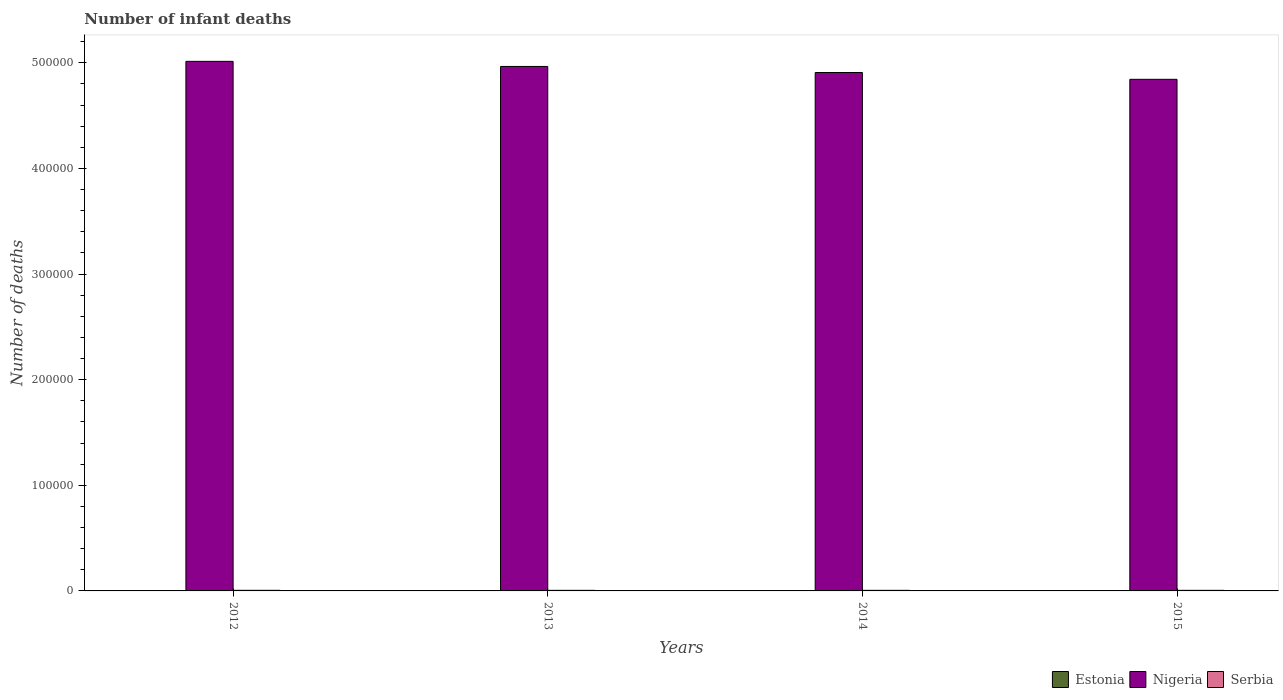How many different coloured bars are there?
Make the answer very short. 3. Are the number of bars on each tick of the X-axis equal?
Give a very brief answer. Yes. How many bars are there on the 3rd tick from the left?
Make the answer very short. 3. How many bars are there on the 4th tick from the right?
Ensure brevity in your answer.  3. What is the label of the 1st group of bars from the left?
Give a very brief answer. 2012. Across all years, what is the maximum number of infant deaths in Nigeria?
Ensure brevity in your answer.  5.01e+05. Across all years, what is the minimum number of infant deaths in Serbia?
Offer a very short reply. 547. In which year was the number of infant deaths in Serbia minimum?
Give a very brief answer. 2015. What is the total number of infant deaths in Estonia in the graph?
Keep it short and to the point. 138. What is the difference between the number of infant deaths in Nigeria in 2012 and that in 2013?
Provide a succinct answer. 4823. What is the difference between the number of infant deaths in Serbia in 2015 and the number of infant deaths in Nigeria in 2012?
Make the answer very short. -5.01e+05. What is the average number of infant deaths in Nigeria per year?
Your answer should be very brief. 4.93e+05. In the year 2015, what is the difference between the number of infant deaths in Serbia and number of infant deaths in Nigeria?
Your answer should be compact. -4.84e+05. What is the ratio of the number of infant deaths in Nigeria in 2013 to that in 2014?
Offer a very short reply. 1.01. Is the number of infant deaths in Serbia in 2012 less than that in 2013?
Provide a short and direct response. No. Is the difference between the number of infant deaths in Serbia in 2014 and 2015 greater than the difference between the number of infant deaths in Nigeria in 2014 and 2015?
Give a very brief answer. No. What is the difference between the highest and the second highest number of infant deaths in Estonia?
Your answer should be compact. 6. In how many years, is the number of infant deaths in Serbia greater than the average number of infant deaths in Serbia taken over all years?
Provide a short and direct response. 1. Is the sum of the number of infant deaths in Estonia in 2014 and 2015 greater than the maximum number of infant deaths in Nigeria across all years?
Give a very brief answer. No. What does the 2nd bar from the left in 2012 represents?
Give a very brief answer. Nigeria. What does the 2nd bar from the right in 2013 represents?
Offer a very short reply. Nigeria. How many bars are there?
Make the answer very short. 12. What is the difference between two consecutive major ticks on the Y-axis?
Your answer should be very brief. 1.00e+05. Are the values on the major ticks of Y-axis written in scientific E-notation?
Your answer should be compact. No. Does the graph contain any zero values?
Provide a succinct answer. No. Where does the legend appear in the graph?
Provide a short and direct response. Bottom right. How are the legend labels stacked?
Your answer should be compact. Horizontal. What is the title of the graph?
Provide a short and direct response. Number of infant deaths. What is the label or title of the Y-axis?
Offer a very short reply. Number of deaths. What is the Number of deaths in Estonia in 2012?
Your response must be concise. 42. What is the Number of deaths in Nigeria in 2012?
Ensure brevity in your answer.  5.01e+05. What is the Number of deaths of Serbia in 2012?
Provide a short and direct response. 567. What is the Number of deaths of Estonia in 2013?
Your answer should be compact. 36. What is the Number of deaths in Nigeria in 2013?
Give a very brief answer. 4.97e+05. What is the Number of deaths of Serbia in 2013?
Ensure brevity in your answer.  552. What is the Number of deaths in Estonia in 2014?
Offer a very short reply. 32. What is the Number of deaths in Nigeria in 2014?
Provide a succinct answer. 4.91e+05. What is the Number of deaths in Serbia in 2014?
Offer a very short reply. 555. What is the Number of deaths in Nigeria in 2015?
Your response must be concise. 4.84e+05. What is the Number of deaths in Serbia in 2015?
Keep it short and to the point. 547. Across all years, what is the maximum Number of deaths of Estonia?
Offer a very short reply. 42. Across all years, what is the maximum Number of deaths in Nigeria?
Your answer should be very brief. 5.01e+05. Across all years, what is the maximum Number of deaths of Serbia?
Your answer should be compact. 567. Across all years, what is the minimum Number of deaths of Nigeria?
Offer a terse response. 4.84e+05. Across all years, what is the minimum Number of deaths in Serbia?
Give a very brief answer. 547. What is the total Number of deaths of Estonia in the graph?
Offer a terse response. 138. What is the total Number of deaths of Nigeria in the graph?
Make the answer very short. 1.97e+06. What is the total Number of deaths of Serbia in the graph?
Your response must be concise. 2221. What is the difference between the Number of deaths in Nigeria in 2012 and that in 2013?
Your answer should be very brief. 4823. What is the difference between the Number of deaths of Estonia in 2012 and that in 2014?
Offer a terse response. 10. What is the difference between the Number of deaths of Nigeria in 2012 and that in 2014?
Give a very brief answer. 1.06e+04. What is the difference between the Number of deaths of Serbia in 2012 and that in 2014?
Your answer should be very brief. 12. What is the difference between the Number of deaths in Estonia in 2012 and that in 2015?
Give a very brief answer. 14. What is the difference between the Number of deaths of Nigeria in 2012 and that in 2015?
Ensure brevity in your answer.  1.70e+04. What is the difference between the Number of deaths of Estonia in 2013 and that in 2014?
Keep it short and to the point. 4. What is the difference between the Number of deaths in Nigeria in 2013 and that in 2014?
Your answer should be very brief. 5749. What is the difference between the Number of deaths in Serbia in 2013 and that in 2014?
Make the answer very short. -3. What is the difference between the Number of deaths of Nigeria in 2013 and that in 2015?
Your response must be concise. 1.22e+04. What is the difference between the Number of deaths in Nigeria in 2014 and that in 2015?
Your response must be concise. 6444. What is the difference between the Number of deaths in Estonia in 2012 and the Number of deaths in Nigeria in 2013?
Provide a short and direct response. -4.97e+05. What is the difference between the Number of deaths in Estonia in 2012 and the Number of deaths in Serbia in 2013?
Provide a short and direct response. -510. What is the difference between the Number of deaths in Nigeria in 2012 and the Number of deaths in Serbia in 2013?
Keep it short and to the point. 5.01e+05. What is the difference between the Number of deaths in Estonia in 2012 and the Number of deaths in Nigeria in 2014?
Your response must be concise. -4.91e+05. What is the difference between the Number of deaths of Estonia in 2012 and the Number of deaths of Serbia in 2014?
Keep it short and to the point. -513. What is the difference between the Number of deaths of Nigeria in 2012 and the Number of deaths of Serbia in 2014?
Keep it short and to the point. 5.01e+05. What is the difference between the Number of deaths of Estonia in 2012 and the Number of deaths of Nigeria in 2015?
Offer a very short reply. -4.84e+05. What is the difference between the Number of deaths of Estonia in 2012 and the Number of deaths of Serbia in 2015?
Offer a terse response. -505. What is the difference between the Number of deaths in Nigeria in 2012 and the Number of deaths in Serbia in 2015?
Offer a terse response. 5.01e+05. What is the difference between the Number of deaths of Estonia in 2013 and the Number of deaths of Nigeria in 2014?
Offer a very short reply. -4.91e+05. What is the difference between the Number of deaths of Estonia in 2013 and the Number of deaths of Serbia in 2014?
Make the answer very short. -519. What is the difference between the Number of deaths in Nigeria in 2013 and the Number of deaths in Serbia in 2014?
Give a very brief answer. 4.96e+05. What is the difference between the Number of deaths of Estonia in 2013 and the Number of deaths of Nigeria in 2015?
Offer a very short reply. -4.84e+05. What is the difference between the Number of deaths of Estonia in 2013 and the Number of deaths of Serbia in 2015?
Offer a very short reply. -511. What is the difference between the Number of deaths of Nigeria in 2013 and the Number of deaths of Serbia in 2015?
Provide a short and direct response. 4.96e+05. What is the difference between the Number of deaths in Estonia in 2014 and the Number of deaths in Nigeria in 2015?
Offer a terse response. -4.84e+05. What is the difference between the Number of deaths of Estonia in 2014 and the Number of deaths of Serbia in 2015?
Offer a terse response. -515. What is the difference between the Number of deaths of Nigeria in 2014 and the Number of deaths of Serbia in 2015?
Provide a short and direct response. 4.90e+05. What is the average Number of deaths in Estonia per year?
Your response must be concise. 34.5. What is the average Number of deaths of Nigeria per year?
Provide a succinct answer. 4.93e+05. What is the average Number of deaths in Serbia per year?
Your response must be concise. 555.25. In the year 2012, what is the difference between the Number of deaths in Estonia and Number of deaths in Nigeria?
Give a very brief answer. -5.01e+05. In the year 2012, what is the difference between the Number of deaths of Estonia and Number of deaths of Serbia?
Give a very brief answer. -525. In the year 2012, what is the difference between the Number of deaths of Nigeria and Number of deaths of Serbia?
Offer a very short reply. 5.01e+05. In the year 2013, what is the difference between the Number of deaths in Estonia and Number of deaths in Nigeria?
Offer a very short reply. -4.97e+05. In the year 2013, what is the difference between the Number of deaths of Estonia and Number of deaths of Serbia?
Offer a very short reply. -516. In the year 2013, what is the difference between the Number of deaths in Nigeria and Number of deaths in Serbia?
Your response must be concise. 4.96e+05. In the year 2014, what is the difference between the Number of deaths in Estonia and Number of deaths in Nigeria?
Provide a succinct answer. -4.91e+05. In the year 2014, what is the difference between the Number of deaths in Estonia and Number of deaths in Serbia?
Your answer should be very brief. -523. In the year 2014, what is the difference between the Number of deaths in Nigeria and Number of deaths in Serbia?
Make the answer very short. 4.90e+05. In the year 2015, what is the difference between the Number of deaths of Estonia and Number of deaths of Nigeria?
Offer a terse response. -4.84e+05. In the year 2015, what is the difference between the Number of deaths in Estonia and Number of deaths in Serbia?
Keep it short and to the point. -519. In the year 2015, what is the difference between the Number of deaths in Nigeria and Number of deaths in Serbia?
Offer a terse response. 4.84e+05. What is the ratio of the Number of deaths of Nigeria in 2012 to that in 2013?
Offer a terse response. 1.01. What is the ratio of the Number of deaths in Serbia in 2012 to that in 2013?
Ensure brevity in your answer.  1.03. What is the ratio of the Number of deaths in Estonia in 2012 to that in 2014?
Your answer should be very brief. 1.31. What is the ratio of the Number of deaths in Nigeria in 2012 to that in 2014?
Your answer should be compact. 1.02. What is the ratio of the Number of deaths of Serbia in 2012 to that in 2014?
Offer a terse response. 1.02. What is the ratio of the Number of deaths of Estonia in 2012 to that in 2015?
Offer a terse response. 1.5. What is the ratio of the Number of deaths of Nigeria in 2012 to that in 2015?
Make the answer very short. 1.04. What is the ratio of the Number of deaths in Serbia in 2012 to that in 2015?
Your answer should be very brief. 1.04. What is the ratio of the Number of deaths in Nigeria in 2013 to that in 2014?
Give a very brief answer. 1.01. What is the ratio of the Number of deaths of Nigeria in 2013 to that in 2015?
Offer a terse response. 1.03. What is the ratio of the Number of deaths of Serbia in 2013 to that in 2015?
Make the answer very short. 1.01. What is the ratio of the Number of deaths in Estonia in 2014 to that in 2015?
Provide a succinct answer. 1.14. What is the ratio of the Number of deaths in Nigeria in 2014 to that in 2015?
Ensure brevity in your answer.  1.01. What is the ratio of the Number of deaths of Serbia in 2014 to that in 2015?
Offer a terse response. 1.01. What is the difference between the highest and the second highest Number of deaths in Estonia?
Your response must be concise. 6. What is the difference between the highest and the second highest Number of deaths of Nigeria?
Provide a succinct answer. 4823. What is the difference between the highest and the second highest Number of deaths in Serbia?
Keep it short and to the point. 12. What is the difference between the highest and the lowest Number of deaths in Nigeria?
Offer a very short reply. 1.70e+04. What is the difference between the highest and the lowest Number of deaths in Serbia?
Offer a very short reply. 20. 